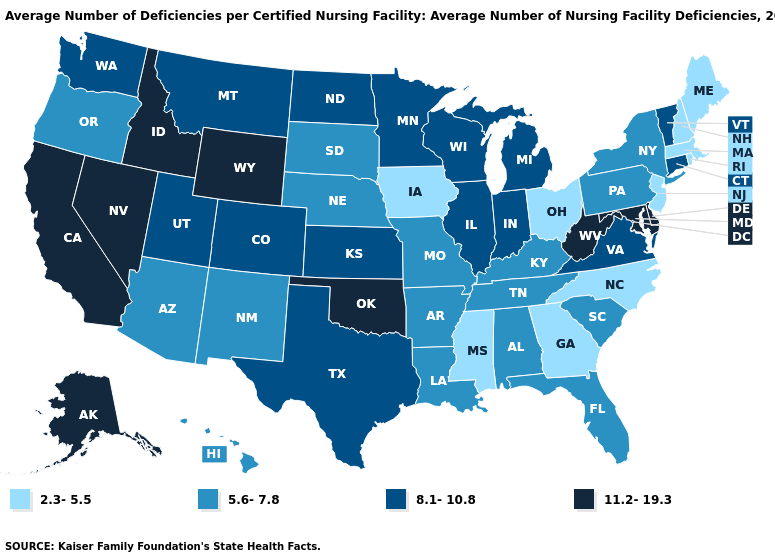Among the states that border Rhode Island , which have the highest value?
Give a very brief answer. Connecticut. Name the states that have a value in the range 8.1-10.8?
Give a very brief answer. Colorado, Connecticut, Illinois, Indiana, Kansas, Michigan, Minnesota, Montana, North Dakota, Texas, Utah, Vermont, Virginia, Washington, Wisconsin. What is the value of Connecticut?
Keep it brief. 8.1-10.8. Which states have the highest value in the USA?
Write a very short answer. Alaska, California, Delaware, Idaho, Maryland, Nevada, Oklahoma, West Virginia, Wyoming. Does Nevada have the highest value in the USA?
Be succinct. Yes. Which states hav the highest value in the West?
Concise answer only. Alaska, California, Idaho, Nevada, Wyoming. Among the states that border North Dakota , which have the highest value?
Be succinct. Minnesota, Montana. Among the states that border North Dakota , which have the highest value?
Quick response, please. Minnesota, Montana. What is the value of Oklahoma?
Answer briefly. 11.2-19.3. How many symbols are there in the legend?
Answer briefly. 4. What is the value of Nebraska?
Quick response, please. 5.6-7.8. Does Tennessee have the lowest value in the South?
Quick response, please. No. What is the lowest value in the Northeast?
Quick response, please. 2.3-5.5. Is the legend a continuous bar?
Write a very short answer. No. Name the states that have a value in the range 5.6-7.8?
Write a very short answer. Alabama, Arizona, Arkansas, Florida, Hawaii, Kentucky, Louisiana, Missouri, Nebraska, New Mexico, New York, Oregon, Pennsylvania, South Carolina, South Dakota, Tennessee. 